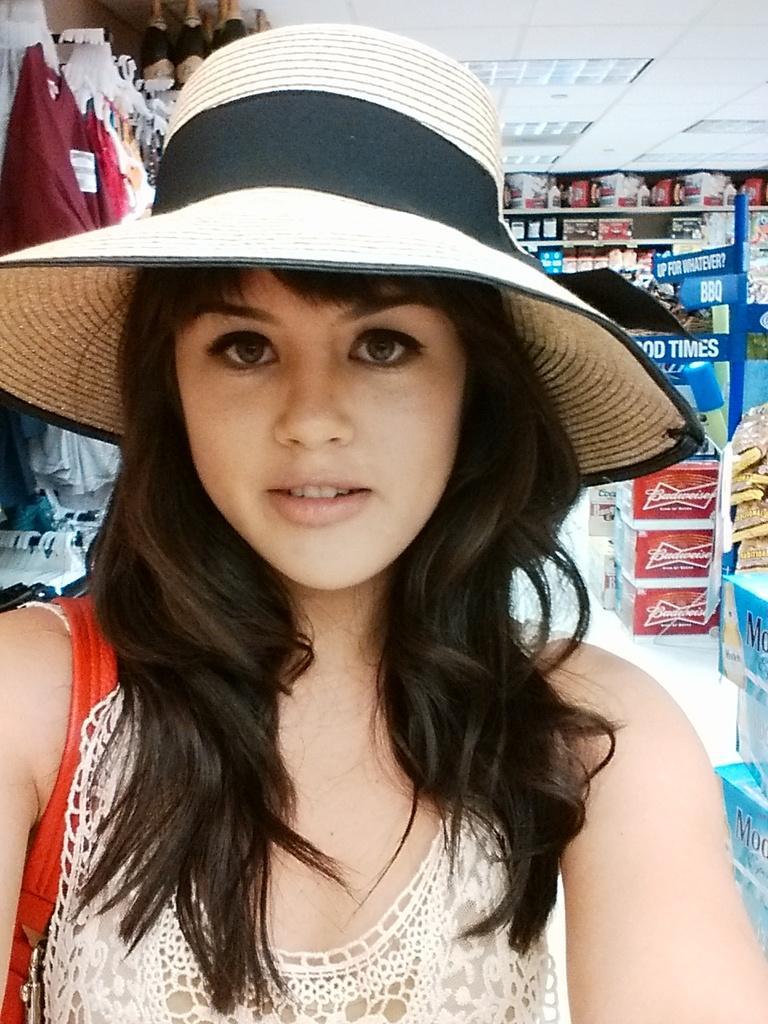Describe this image in one or two sentences. In this image we can see a girl wearing a hat. In the background there are things placed in the shelves and we can see cartoons. On the left there are clothes placed on the hanger. At the top there are lights. 